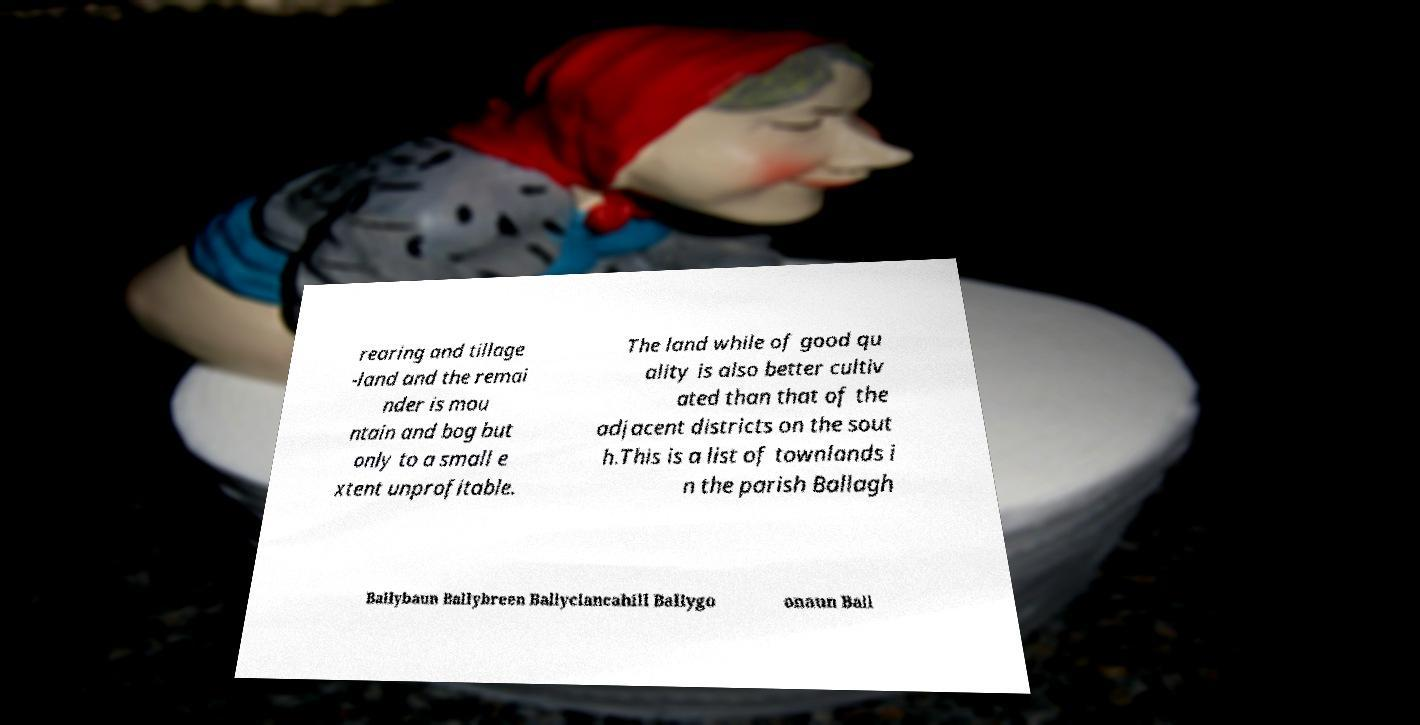For documentation purposes, I need the text within this image transcribed. Could you provide that? rearing and tillage -land and the remai nder is mou ntain and bog but only to a small e xtent unprofitable. The land while of good qu ality is also better cultiv ated than that of the adjacent districts on the sout h.This is a list of townlands i n the parish Ballagh Ballybaun Ballybreen Ballyclancahill Ballygo onaun Ball 